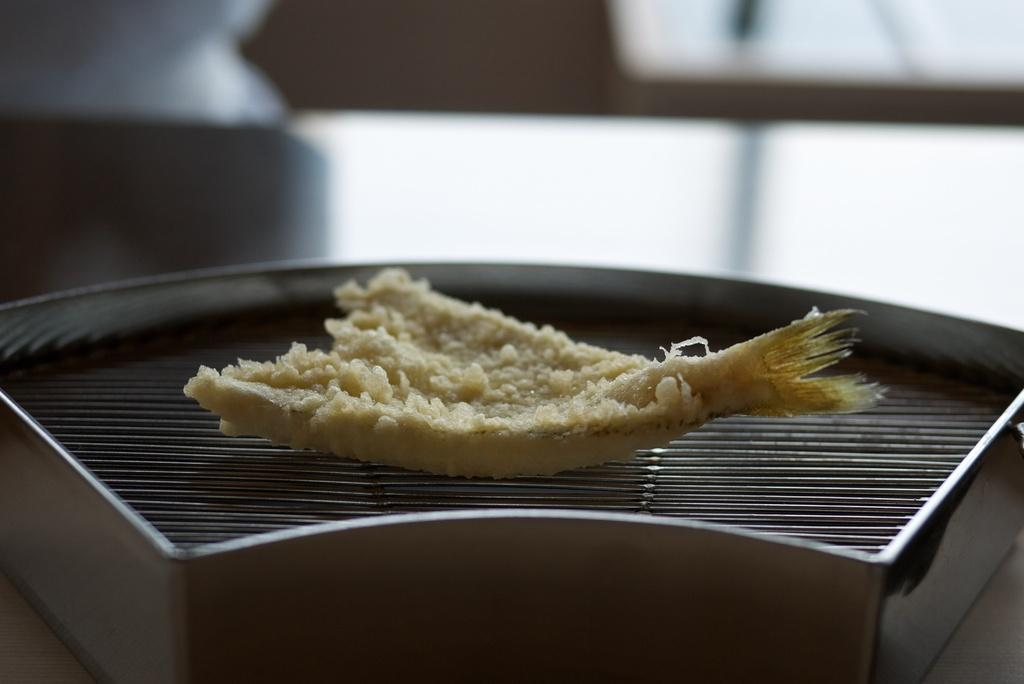What is being cooked on the grill in the image? There is food on the grill in the image. Can you describe any specific details about the image? The top part of the image is blurred. What type of nail is being used to hold the idea in place in the image? There is no nail or idea present in the image; it only features food on a grill and a blurred top part. 